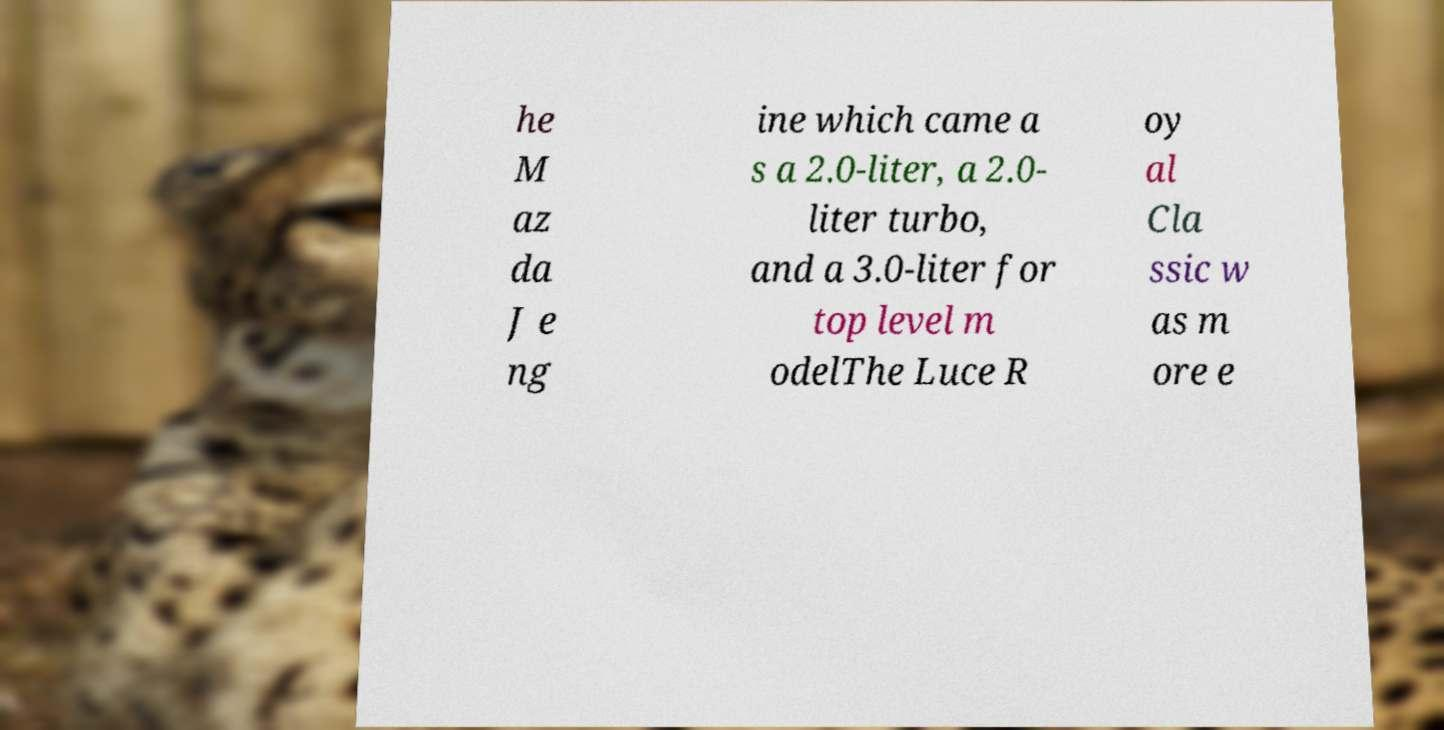Can you read and provide the text displayed in the image?This photo seems to have some interesting text. Can you extract and type it out for me? he M az da J e ng ine which came a s a 2.0-liter, a 2.0- liter turbo, and a 3.0-liter for top level m odelThe Luce R oy al Cla ssic w as m ore e 